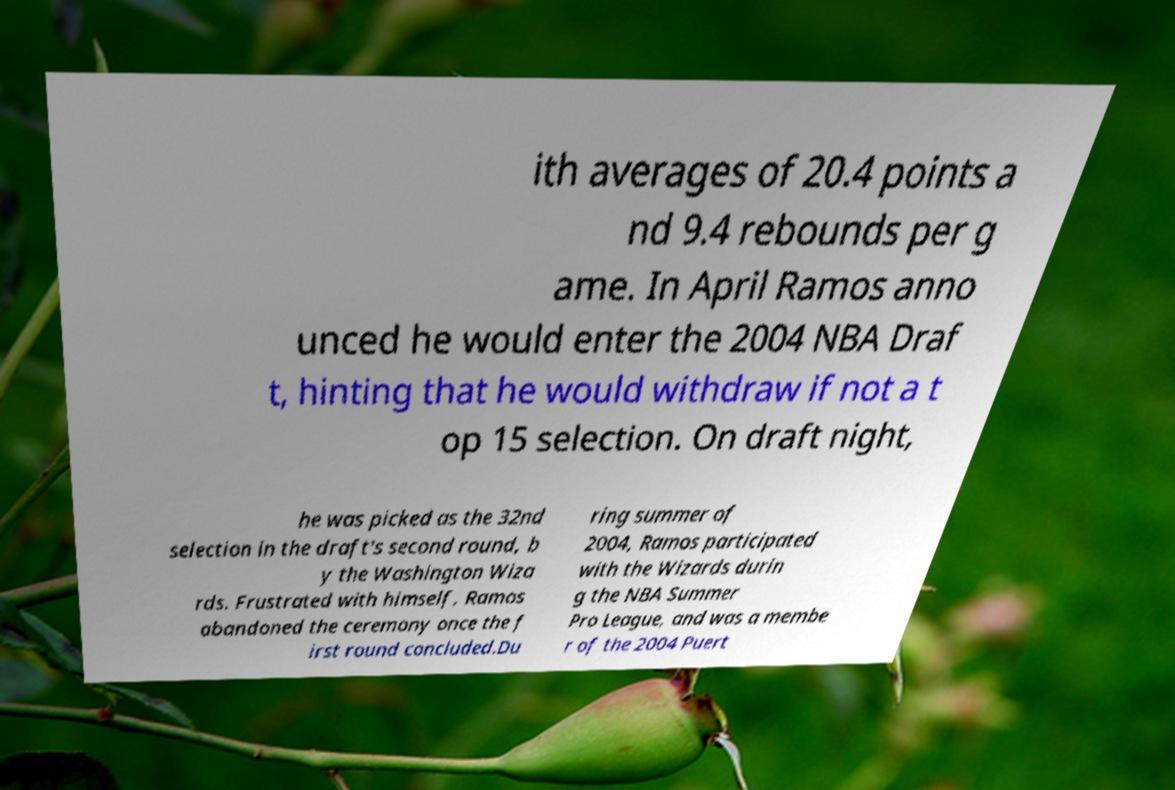I need the written content from this picture converted into text. Can you do that? ith averages of 20.4 points a nd 9.4 rebounds per g ame. In April Ramos anno unced he would enter the 2004 NBA Draf t, hinting that he would withdraw if not a t op 15 selection. On draft night, he was picked as the 32nd selection in the draft's second round, b y the Washington Wiza rds. Frustrated with himself, Ramos abandoned the ceremony once the f irst round concluded.Du ring summer of 2004, Ramos participated with the Wizards durin g the NBA Summer Pro League, and was a membe r of the 2004 Puert 